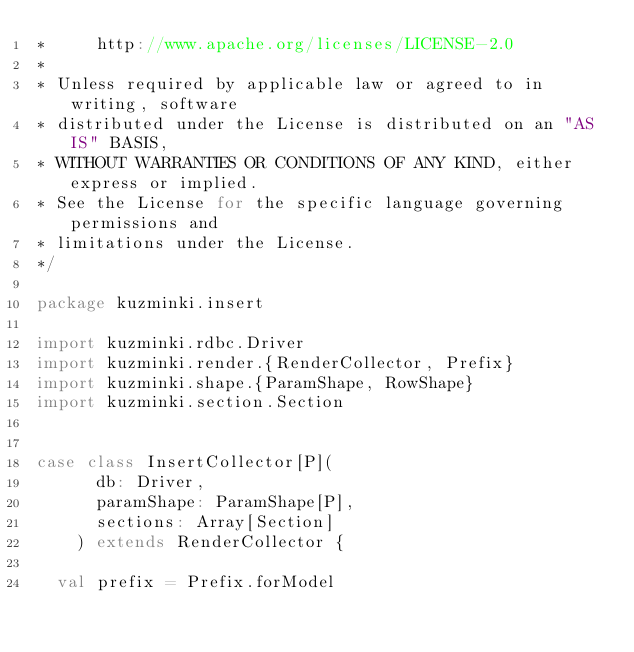Convert code to text. <code><loc_0><loc_0><loc_500><loc_500><_Scala_>*     http://www.apache.org/licenses/LICENSE-2.0
*
* Unless required by applicable law or agreed to in writing, software
* distributed under the License is distributed on an "AS IS" BASIS,
* WITHOUT WARRANTIES OR CONDITIONS OF ANY KIND, either express or implied.
* See the License for the specific language governing permissions and
* limitations under the License.
*/

package kuzminki.insert

import kuzminki.rdbc.Driver
import kuzminki.render.{RenderCollector, Prefix}
import kuzminki.shape.{ParamShape, RowShape}
import kuzminki.section.Section


case class InsertCollector[P](
      db: Driver,
      paramShape: ParamShape[P],
      sections: Array[Section]
    ) extends RenderCollector {

  val prefix = Prefix.forModel
</code> 